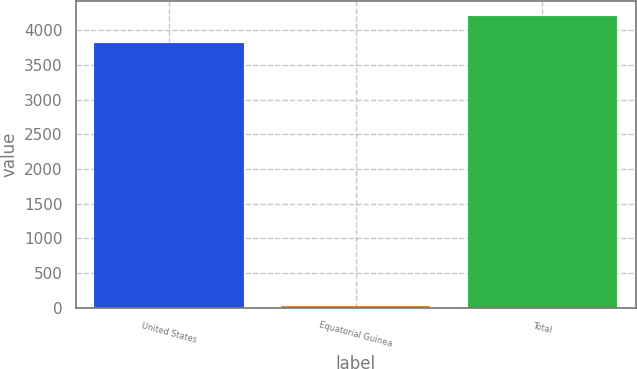Convert chart. <chart><loc_0><loc_0><loc_500><loc_500><bar_chart><fcel>United States<fcel>Equatorial Guinea<fcel>Total<nl><fcel>3821<fcel>21<fcel>4203.9<nl></chart> 